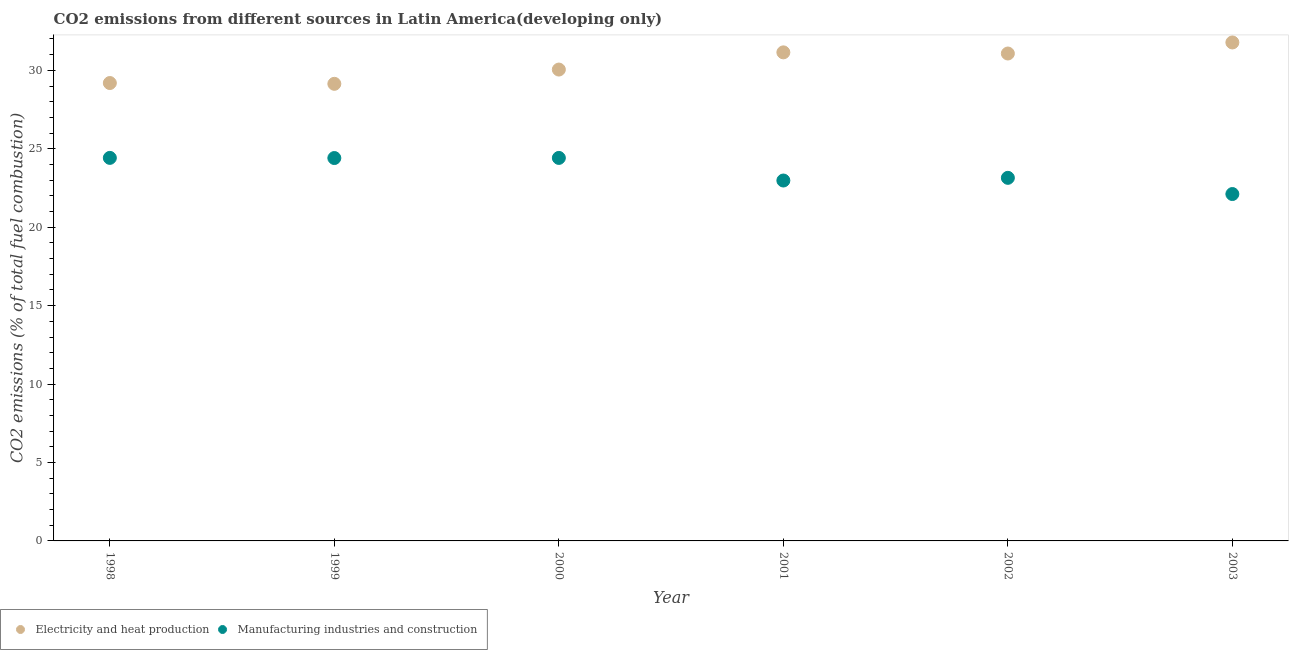Is the number of dotlines equal to the number of legend labels?
Provide a succinct answer. Yes. What is the co2 emissions due to manufacturing industries in 1999?
Provide a short and direct response. 24.41. Across all years, what is the maximum co2 emissions due to manufacturing industries?
Your answer should be compact. 24.42. Across all years, what is the minimum co2 emissions due to manufacturing industries?
Your response must be concise. 22.11. In which year was the co2 emissions due to manufacturing industries minimum?
Provide a short and direct response. 2003. What is the total co2 emissions due to manufacturing industries in the graph?
Your answer should be very brief. 141.48. What is the difference between the co2 emissions due to electricity and heat production in 2000 and that in 2003?
Your answer should be very brief. -1.73. What is the difference between the co2 emissions due to electricity and heat production in 1999 and the co2 emissions due to manufacturing industries in 2000?
Your response must be concise. 4.72. What is the average co2 emissions due to electricity and heat production per year?
Make the answer very short. 30.4. In the year 2002, what is the difference between the co2 emissions due to electricity and heat production and co2 emissions due to manufacturing industries?
Keep it short and to the point. 7.93. In how many years, is the co2 emissions due to manufacturing industries greater than 15 %?
Offer a very short reply. 6. What is the ratio of the co2 emissions due to manufacturing industries in 1998 to that in 1999?
Make the answer very short. 1. Is the co2 emissions due to electricity and heat production in 1999 less than that in 2002?
Offer a terse response. Yes. Is the difference between the co2 emissions due to manufacturing industries in 2000 and 2002 greater than the difference between the co2 emissions due to electricity and heat production in 2000 and 2002?
Ensure brevity in your answer.  Yes. What is the difference between the highest and the second highest co2 emissions due to electricity and heat production?
Provide a succinct answer. 0.63. What is the difference between the highest and the lowest co2 emissions due to electricity and heat production?
Offer a very short reply. 2.64. In how many years, is the co2 emissions due to electricity and heat production greater than the average co2 emissions due to electricity and heat production taken over all years?
Make the answer very short. 3. Is the sum of the co2 emissions due to manufacturing industries in 1999 and 2001 greater than the maximum co2 emissions due to electricity and heat production across all years?
Keep it short and to the point. Yes. Is the co2 emissions due to manufacturing industries strictly less than the co2 emissions due to electricity and heat production over the years?
Make the answer very short. Yes. What is the difference between two consecutive major ticks on the Y-axis?
Offer a terse response. 5. Are the values on the major ticks of Y-axis written in scientific E-notation?
Provide a short and direct response. No. Does the graph contain any zero values?
Provide a succinct answer. No. Does the graph contain grids?
Offer a very short reply. No. How are the legend labels stacked?
Offer a terse response. Horizontal. What is the title of the graph?
Ensure brevity in your answer.  CO2 emissions from different sources in Latin America(developing only). What is the label or title of the Y-axis?
Provide a short and direct response. CO2 emissions (% of total fuel combustion). What is the CO2 emissions (% of total fuel combustion) in Electricity and heat production in 1998?
Provide a short and direct response. 29.19. What is the CO2 emissions (% of total fuel combustion) in Manufacturing industries and construction in 1998?
Offer a terse response. 24.42. What is the CO2 emissions (% of total fuel combustion) in Electricity and heat production in 1999?
Keep it short and to the point. 29.14. What is the CO2 emissions (% of total fuel combustion) in Manufacturing industries and construction in 1999?
Make the answer very short. 24.41. What is the CO2 emissions (% of total fuel combustion) of Electricity and heat production in 2000?
Offer a very short reply. 30.05. What is the CO2 emissions (% of total fuel combustion) of Manufacturing industries and construction in 2000?
Your answer should be very brief. 24.42. What is the CO2 emissions (% of total fuel combustion) in Electricity and heat production in 2001?
Provide a short and direct response. 31.15. What is the CO2 emissions (% of total fuel combustion) in Manufacturing industries and construction in 2001?
Your response must be concise. 22.98. What is the CO2 emissions (% of total fuel combustion) of Electricity and heat production in 2002?
Provide a short and direct response. 31.07. What is the CO2 emissions (% of total fuel combustion) of Manufacturing industries and construction in 2002?
Ensure brevity in your answer.  23.15. What is the CO2 emissions (% of total fuel combustion) in Electricity and heat production in 2003?
Offer a terse response. 31.78. What is the CO2 emissions (% of total fuel combustion) in Manufacturing industries and construction in 2003?
Provide a succinct answer. 22.11. Across all years, what is the maximum CO2 emissions (% of total fuel combustion) of Electricity and heat production?
Keep it short and to the point. 31.78. Across all years, what is the maximum CO2 emissions (% of total fuel combustion) in Manufacturing industries and construction?
Make the answer very short. 24.42. Across all years, what is the minimum CO2 emissions (% of total fuel combustion) of Electricity and heat production?
Give a very brief answer. 29.14. Across all years, what is the minimum CO2 emissions (% of total fuel combustion) in Manufacturing industries and construction?
Give a very brief answer. 22.11. What is the total CO2 emissions (% of total fuel combustion) in Electricity and heat production in the graph?
Your response must be concise. 182.38. What is the total CO2 emissions (% of total fuel combustion) in Manufacturing industries and construction in the graph?
Make the answer very short. 141.48. What is the difference between the CO2 emissions (% of total fuel combustion) of Electricity and heat production in 1998 and that in 1999?
Offer a very short reply. 0.05. What is the difference between the CO2 emissions (% of total fuel combustion) of Manufacturing industries and construction in 1998 and that in 1999?
Give a very brief answer. 0.01. What is the difference between the CO2 emissions (% of total fuel combustion) of Electricity and heat production in 1998 and that in 2000?
Give a very brief answer. -0.86. What is the difference between the CO2 emissions (% of total fuel combustion) in Manufacturing industries and construction in 1998 and that in 2000?
Your answer should be very brief. 0. What is the difference between the CO2 emissions (% of total fuel combustion) of Electricity and heat production in 1998 and that in 2001?
Provide a short and direct response. -1.96. What is the difference between the CO2 emissions (% of total fuel combustion) of Manufacturing industries and construction in 1998 and that in 2001?
Ensure brevity in your answer.  1.44. What is the difference between the CO2 emissions (% of total fuel combustion) of Electricity and heat production in 1998 and that in 2002?
Give a very brief answer. -1.88. What is the difference between the CO2 emissions (% of total fuel combustion) of Manufacturing industries and construction in 1998 and that in 2002?
Your response must be concise. 1.27. What is the difference between the CO2 emissions (% of total fuel combustion) of Electricity and heat production in 1998 and that in 2003?
Ensure brevity in your answer.  -2.59. What is the difference between the CO2 emissions (% of total fuel combustion) in Manufacturing industries and construction in 1998 and that in 2003?
Offer a terse response. 2.31. What is the difference between the CO2 emissions (% of total fuel combustion) in Electricity and heat production in 1999 and that in 2000?
Offer a terse response. -0.91. What is the difference between the CO2 emissions (% of total fuel combustion) in Manufacturing industries and construction in 1999 and that in 2000?
Your answer should be compact. -0.01. What is the difference between the CO2 emissions (% of total fuel combustion) of Electricity and heat production in 1999 and that in 2001?
Provide a succinct answer. -2.01. What is the difference between the CO2 emissions (% of total fuel combustion) of Manufacturing industries and construction in 1999 and that in 2001?
Offer a terse response. 1.43. What is the difference between the CO2 emissions (% of total fuel combustion) of Electricity and heat production in 1999 and that in 2002?
Your answer should be very brief. -1.93. What is the difference between the CO2 emissions (% of total fuel combustion) of Manufacturing industries and construction in 1999 and that in 2002?
Your answer should be very brief. 1.26. What is the difference between the CO2 emissions (% of total fuel combustion) of Electricity and heat production in 1999 and that in 2003?
Your answer should be very brief. -2.64. What is the difference between the CO2 emissions (% of total fuel combustion) of Manufacturing industries and construction in 1999 and that in 2003?
Keep it short and to the point. 2.29. What is the difference between the CO2 emissions (% of total fuel combustion) of Electricity and heat production in 2000 and that in 2001?
Keep it short and to the point. -1.1. What is the difference between the CO2 emissions (% of total fuel combustion) in Manufacturing industries and construction in 2000 and that in 2001?
Provide a succinct answer. 1.44. What is the difference between the CO2 emissions (% of total fuel combustion) in Electricity and heat production in 2000 and that in 2002?
Offer a very short reply. -1.02. What is the difference between the CO2 emissions (% of total fuel combustion) in Manufacturing industries and construction in 2000 and that in 2002?
Provide a short and direct response. 1.27. What is the difference between the CO2 emissions (% of total fuel combustion) of Electricity and heat production in 2000 and that in 2003?
Offer a very short reply. -1.73. What is the difference between the CO2 emissions (% of total fuel combustion) in Manufacturing industries and construction in 2000 and that in 2003?
Ensure brevity in your answer.  2.3. What is the difference between the CO2 emissions (% of total fuel combustion) in Electricity and heat production in 2001 and that in 2002?
Make the answer very short. 0.07. What is the difference between the CO2 emissions (% of total fuel combustion) of Manufacturing industries and construction in 2001 and that in 2002?
Provide a short and direct response. -0.17. What is the difference between the CO2 emissions (% of total fuel combustion) in Electricity and heat production in 2001 and that in 2003?
Keep it short and to the point. -0.63. What is the difference between the CO2 emissions (% of total fuel combustion) in Manufacturing industries and construction in 2001 and that in 2003?
Offer a terse response. 0.86. What is the difference between the CO2 emissions (% of total fuel combustion) of Electricity and heat production in 2002 and that in 2003?
Offer a terse response. -0.7. What is the difference between the CO2 emissions (% of total fuel combustion) in Manufacturing industries and construction in 2002 and that in 2003?
Offer a terse response. 1.03. What is the difference between the CO2 emissions (% of total fuel combustion) of Electricity and heat production in 1998 and the CO2 emissions (% of total fuel combustion) of Manufacturing industries and construction in 1999?
Give a very brief answer. 4.78. What is the difference between the CO2 emissions (% of total fuel combustion) of Electricity and heat production in 1998 and the CO2 emissions (% of total fuel combustion) of Manufacturing industries and construction in 2000?
Provide a short and direct response. 4.77. What is the difference between the CO2 emissions (% of total fuel combustion) in Electricity and heat production in 1998 and the CO2 emissions (% of total fuel combustion) in Manufacturing industries and construction in 2001?
Your response must be concise. 6.21. What is the difference between the CO2 emissions (% of total fuel combustion) in Electricity and heat production in 1998 and the CO2 emissions (% of total fuel combustion) in Manufacturing industries and construction in 2002?
Provide a succinct answer. 6.04. What is the difference between the CO2 emissions (% of total fuel combustion) in Electricity and heat production in 1998 and the CO2 emissions (% of total fuel combustion) in Manufacturing industries and construction in 2003?
Provide a succinct answer. 7.08. What is the difference between the CO2 emissions (% of total fuel combustion) of Electricity and heat production in 1999 and the CO2 emissions (% of total fuel combustion) of Manufacturing industries and construction in 2000?
Give a very brief answer. 4.72. What is the difference between the CO2 emissions (% of total fuel combustion) in Electricity and heat production in 1999 and the CO2 emissions (% of total fuel combustion) in Manufacturing industries and construction in 2001?
Keep it short and to the point. 6.16. What is the difference between the CO2 emissions (% of total fuel combustion) in Electricity and heat production in 1999 and the CO2 emissions (% of total fuel combustion) in Manufacturing industries and construction in 2002?
Give a very brief answer. 5.99. What is the difference between the CO2 emissions (% of total fuel combustion) in Electricity and heat production in 1999 and the CO2 emissions (% of total fuel combustion) in Manufacturing industries and construction in 2003?
Provide a short and direct response. 7.03. What is the difference between the CO2 emissions (% of total fuel combustion) of Electricity and heat production in 2000 and the CO2 emissions (% of total fuel combustion) of Manufacturing industries and construction in 2001?
Ensure brevity in your answer.  7.07. What is the difference between the CO2 emissions (% of total fuel combustion) in Electricity and heat production in 2000 and the CO2 emissions (% of total fuel combustion) in Manufacturing industries and construction in 2002?
Give a very brief answer. 6.9. What is the difference between the CO2 emissions (% of total fuel combustion) in Electricity and heat production in 2000 and the CO2 emissions (% of total fuel combustion) in Manufacturing industries and construction in 2003?
Provide a short and direct response. 7.94. What is the difference between the CO2 emissions (% of total fuel combustion) of Electricity and heat production in 2001 and the CO2 emissions (% of total fuel combustion) of Manufacturing industries and construction in 2002?
Keep it short and to the point. 8. What is the difference between the CO2 emissions (% of total fuel combustion) of Electricity and heat production in 2001 and the CO2 emissions (% of total fuel combustion) of Manufacturing industries and construction in 2003?
Your answer should be compact. 9.03. What is the difference between the CO2 emissions (% of total fuel combustion) of Electricity and heat production in 2002 and the CO2 emissions (% of total fuel combustion) of Manufacturing industries and construction in 2003?
Offer a very short reply. 8.96. What is the average CO2 emissions (% of total fuel combustion) of Electricity and heat production per year?
Your answer should be compact. 30.4. What is the average CO2 emissions (% of total fuel combustion) in Manufacturing industries and construction per year?
Offer a very short reply. 23.58. In the year 1998, what is the difference between the CO2 emissions (% of total fuel combustion) of Electricity and heat production and CO2 emissions (% of total fuel combustion) of Manufacturing industries and construction?
Keep it short and to the point. 4.77. In the year 1999, what is the difference between the CO2 emissions (% of total fuel combustion) in Electricity and heat production and CO2 emissions (% of total fuel combustion) in Manufacturing industries and construction?
Offer a terse response. 4.73. In the year 2000, what is the difference between the CO2 emissions (% of total fuel combustion) in Electricity and heat production and CO2 emissions (% of total fuel combustion) in Manufacturing industries and construction?
Ensure brevity in your answer.  5.63. In the year 2001, what is the difference between the CO2 emissions (% of total fuel combustion) of Electricity and heat production and CO2 emissions (% of total fuel combustion) of Manufacturing industries and construction?
Your response must be concise. 8.17. In the year 2002, what is the difference between the CO2 emissions (% of total fuel combustion) in Electricity and heat production and CO2 emissions (% of total fuel combustion) in Manufacturing industries and construction?
Your response must be concise. 7.93. In the year 2003, what is the difference between the CO2 emissions (% of total fuel combustion) in Electricity and heat production and CO2 emissions (% of total fuel combustion) in Manufacturing industries and construction?
Offer a very short reply. 9.66. What is the ratio of the CO2 emissions (% of total fuel combustion) of Electricity and heat production in 1998 to that in 2000?
Your response must be concise. 0.97. What is the ratio of the CO2 emissions (% of total fuel combustion) of Manufacturing industries and construction in 1998 to that in 2000?
Ensure brevity in your answer.  1. What is the ratio of the CO2 emissions (% of total fuel combustion) of Electricity and heat production in 1998 to that in 2001?
Your response must be concise. 0.94. What is the ratio of the CO2 emissions (% of total fuel combustion) of Manufacturing industries and construction in 1998 to that in 2001?
Your answer should be compact. 1.06. What is the ratio of the CO2 emissions (% of total fuel combustion) in Electricity and heat production in 1998 to that in 2002?
Keep it short and to the point. 0.94. What is the ratio of the CO2 emissions (% of total fuel combustion) of Manufacturing industries and construction in 1998 to that in 2002?
Provide a short and direct response. 1.05. What is the ratio of the CO2 emissions (% of total fuel combustion) in Electricity and heat production in 1998 to that in 2003?
Your answer should be very brief. 0.92. What is the ratio of the CO2 emissions (% of total fuel combustion) in Manufacturing industries and construction in 1998 to that in 2003?
Your response must be concise. 1.1. What is the ratio of the CO2 emissions (% of total fuel combustion) of Electricity and heat production in 1999 to that in 2000?
Keep it short and to the point. 0.97. What is the ratio of the CO2 emissions (% of total fuel combustion) of Electricity and heat production in 1999 to that in 2001?
Offer a terse response. 0.94. What is the ratio of the CO2 emissions (% of total fuel combustion) of Manufacturing industries and construction in 1999 to that in 2001?
Provide a succinct answer. 1.06. What is the ratio of the CO2 emissions (% of total fuel combustion) of Electricity and heat production in 1999 to that in 2002?
Give a very brief answer. 0.94. What is the ratio of the CO2 emissions (% of total fuel combustion) of Manufacturing industries and construction in 1999 to that in 2002?
Give a very brief answer. 1.05. What is the ratio of the CO2 emissions (% of total fuel combustion) in Electricity and heat production in 1999 to that in 2003?
Your answer should be compact. 0.92. What is the ratio of the CO2 emissions (% of total fuel combustion) of Manufacturing industries and construction in 1999 to that in 2003?
Provide a succinct answer. 1.1. What is the ratio of the CO2 emissions (% of total fuel combustion) in Electricity and heat production in 2000 to that in 2001?
Provide a short and direct response. 0.96. What is the ratio of the CO2 emissions (% of total fuel combustion) in Manufacturing industries and construction in 2000 to that in 2001?
Your answer should be very brief. 1.06. What is the ratio of the CO2 emissions (% of total fuel combustion) in Electricity and heat production in 2000 to that in 2002?
Ensure brevity in your answer.  0.97. What is the ratio of the CO2 emissions (% of total fuel combustion) of Manufacturing industries and construction in 2000 to that in 2002?
Provide a succinct answer. 1.05. What is the ratio of the CO2 emissions (% of total fuel combustion) in Electricity and heat production in 2000 to that in 2003?
Make the answer very short. 0.95. What is the ratio of the CO2 emissions (% of total fuel combustion) of Manufacturing industries and construction in 2000 to that in 2003?
Your answer should be very brief. 1.1. What is the ratio of the CO2 emissions (% of total fuel combustion) in Electricity and heat production in 2001 to that in 2003?
Your answer should be compact. 0.98. What is the ratio of the CO2 emissions (% of total fuel combustion) of Manufacturing industries and construction in 2001 to that in 2003?
Offer a terse response. 1.04. What is the ratio of the CO2 emissions (% of total fuel combustion) of Electricity and heat production in 2002 to that in 2003?
Offer a very short reply. 0.98. What is the ratio of the CO2 emissions (% of total fuel combustion) of Manufacturing industries and construction in 2002 to that in 2003?
Ensure brevity in your answer.  1.05. What is the difference between the highest and the second highest CO2 emissions (% of total fuel combustion) of Electricity and heat production?
Your response must be concise. 0.63. What is the difference between the highest and the second highest CO2 emissions (% of total fuel combustion) in Manufacturing industries and construction?
Your answer should be very brief. 0. What is the difference between the highest and the lowest CO2 emissions (% of total fuel combustion) in Electricity and heat production?
Provide a short and direct response. 2.64. What is the difference between the highest and the lowest CO2 emissions (% of total fuel combustion) in Manufacturing industries and construction?
Keep it short and to the point. 2.31. 